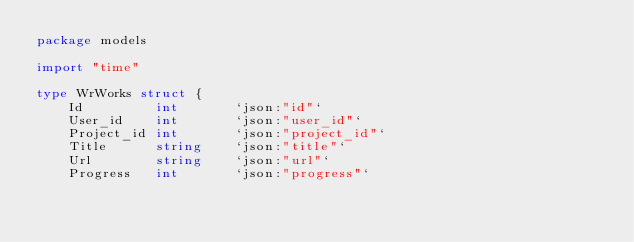<code> <loc_0><loc_0><loc_500><loc_500><_Go_>package models

import "time"

type WrWorks struct {
	Id         int       `json:"id"`
	User_id    int       `json:"user_id"`
	Project_id int       `json:"project_id"`
	Title      string    `json:"title"`
	Url        string    `json:"url"`
	Progress   int       `json:"progress"`</code> 